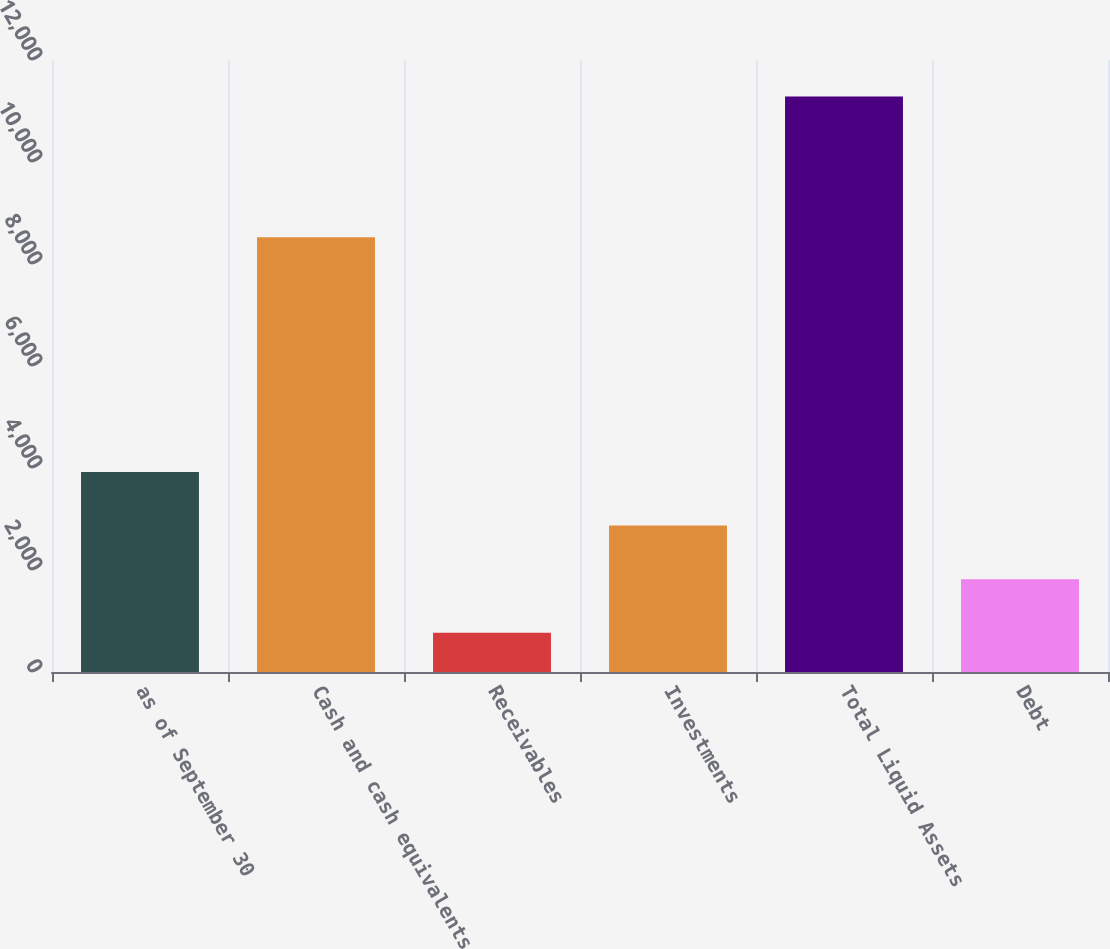<chart> <loc_0><loc_0><loc_500><loc_500><bar_chart><fcel>as of September 30<fcel>Cash and cash equivalents<fcel>Receivables<fcel>Investments<fcel>Total Liquid Assets<fcel>Debt<nl><fcel>3923.35<fcel>8523.3<fcel>767.8<fcel>2871.5<fcel>11286.3<fcel>1819.65<nl></chart> 